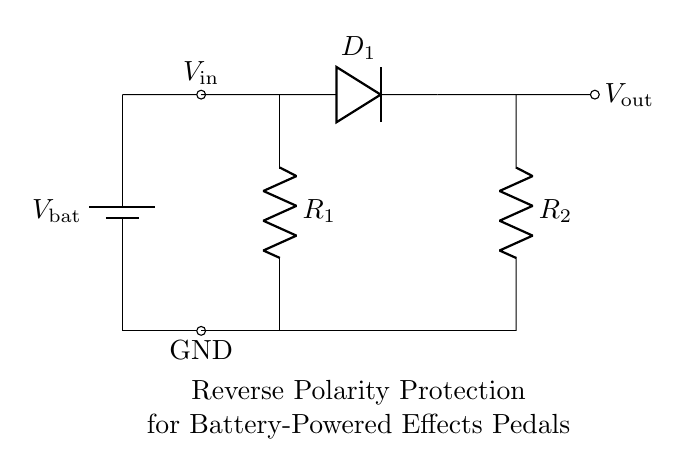What type of battery is shown in the circuit? The circuit features a battery symbol that represents a general battery type, commonly used in effects pedals.
Answer: Battery What are the two resistors labeled in the circuit? The resistors in the circuit are labeled R1 and R2, indicating their roles in establishing current flow and voltage drop across the circuit.
Answer: R1 and R2 What happens to the output voltage if the battery is connected with reverse polarity? The diode D1 will block the current when reverse polarity is applied, preventing voltage from reaching the output, effectively resulting in an output of zero volts.
Answer: Zero volts What component helps prevent reverse current flow? The diode D1 is positioned in such a way that it only allows current to flow in one direction, thereby protecting against reverse current flow when the battery is connected incorrectly.
Answer: Diode What would be a safe output voltage (Vout) when the battery is properly connected? Assuming the battery voltage is standard, and suitable conditions exist, the output voltage Vout will match the battery voltage minus any voltage drop across the diode, typically about 0.7 volts for silicon diodes.
Answer: Battery voltage minus 0.7 volts What is the purpose of the two resistors in the circuit? The resistors R1 and R2 are commonly used to limit current and provide a voltage divider effect, aiding in protecting sensitive components from excessive current and balancing the load.
Answer: Current limiting and voltage division How does this circuit achieve protection against incorrect battery connection? The arrangement of the diode D1 prevents current from reaching the output when the battery leads are connected in reverse; hence, it protects downstream components from damage due to reversed polarity.
Answer: Diode blocking 